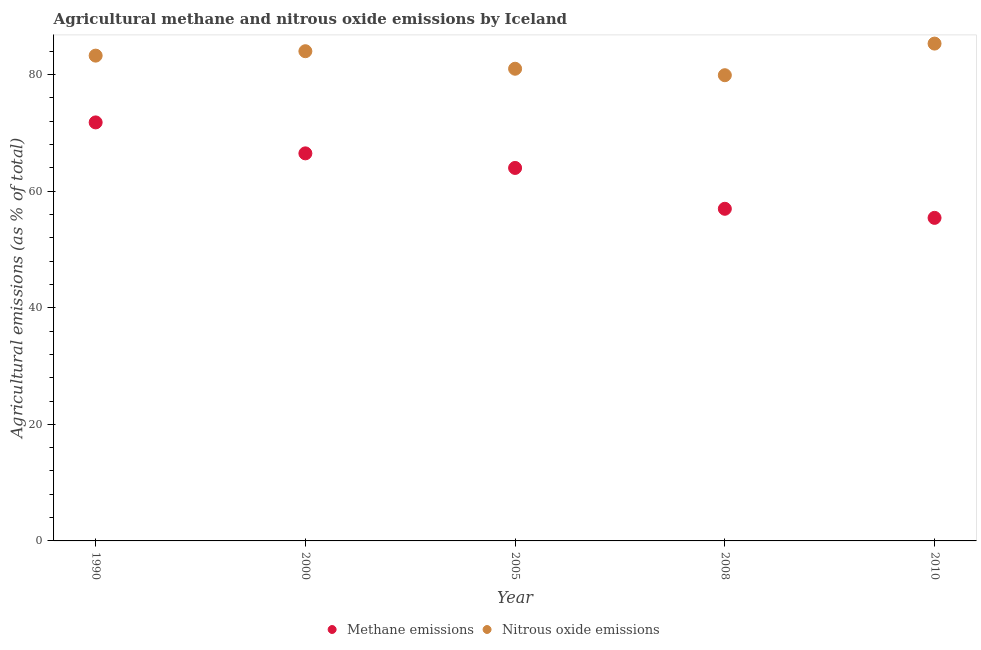How many different coloured dotlines are there?
Ensure brevity in your answer.  2. What is the amount of methane emissions in 2010?
Your answer should be very brief. 55.41. Across all years, what is the maximum amount of nitrous oxide emissions?
Your answer should be compact. 85.31. Across all years, what is the minimum amount of methane emissions?
Provide a succinct answer. 55.41. What is the total amount of nitrous oxide emissions in the graph?
Keep it short and to the point. 413.43. What is the difference between the amount of methane emissions in 2000 and that in 2008?
Your answer should be very brief. 9.51. What is the difference between the amount of methane emissions in 2005 and the amount of nitrous oxide emissions in 2008?
Your answer should be compact. -15.91. What is the average amount of nitrous oxide emissions per year?
Offer a very short reply. 82.69. In the year 1990, what is the difference between the amount of nitrous oxide emissions and amount of methane emissions?
Keep it short and to the point. 11.45. In how many years, is the amount of methane emissions greater than 80 %?
Offer a terse response. 0. What is the ratio of the amount of nitrous oxide emissions in 2000 to that in 2005?
Ensure brevity in your answer.  1.04. What is the difference between the highest and the second highest amount of nitrous oxide emissions?
Your response must be concise. 1.31. What is the difference between the highest and the lowest amount of methane emissions?
Keep it short and to the point. 16.37. Is the amount of nitrous oxide emissions strictly greater than the amount of methane emissions over the years?
Your answer should be very brief. Yes. Is the amount of nitrous oxide emissions strictly less than the amount of methane emissions over the years?
Keep it short and to the point. No. What is the difference between two consecutive major ticks on the Y-axis?
Ensure brevity in your answer.  20. Are the values on the major ticks of Y-axis written in scientific E-notation?
Provide a short and direct response. No. Does the graph contain grids?
Make the answer very short. No. How many legend labels are there?
Ensure brevity in your answer.  2. What is the title of the graph?
Your answer should be compact. Agricultural methane and nitrous oxide emissions by Iceland. What is the label or title of the X-axis?
Make the answer very short. Year. What is the label or title of the Y-axis?
Your response must be concise. Agricultural emissions (as % of total). What is the Agricultural emissions (as % of total) of Methane emissions in 1990?
Your answer should be compact. 71.79. What is the Agricultural emissions (as % of total) in Nitrous oxide emissions in 1990?
Give a very brief answer. 83.24. What is the Agricultural emissions (as % of total) in Methane emissions in 2000?
Your answer should be compact. 66.48. What is the Agricultural emissions (as % of total) in Methane emissions in 2005?
Offer a very short reply. 63.98. What is the Agricultural emissions (as % of total) of Nitrous oxide emissions in 2005?
Your response must be concise. 80.99. What is the Agricultural emissions (as % of total) of Methane emissions in 2008?
Your response must be concise. 56.97. What is the Agricultural emissions (as % of total) in Nitrous oxide emissions in 2008?
Give a very brief answer. 79.88. What is the Agricultural emissions (as % of total) of Methane emissions in 2010?
Your answer should be compact. 55.41. What is the Agricultural emissions (as % of total) in Nitrous oxide emissions in 2010?
Your answer should be very brief. 85.31. Across all years, what is the maximum Agricultural emissions (as % of total) of Methane emissions?
Keep it short and to the point. 71.79. Across all years, what is the maximum Agricultural emissions (as % of total) in Nitrous oxide emissions?
Your answer should be very brief. 85.31. Across all years, what is the minimum Agricultural emissions (as % of total) of Methane emissions?
Provide a short and direct response. 55.41. Across all years, what is the minimum Agricultural emissions (as % of total) in Nitrous oxide emissions?
Make the answer very short. 79.88. What is the total Agricultural emissions (as % of total) in Methane emissions in the graph?
Give a very brief answer. 314.63. What is the total Agricultural emissions (as % of total) in Nitrous oxide emissions in the graph?
Your response must be concise. 413.43. What is the difference between the Agricultural emissions (as % of total) in Methane emissions in 1990 and that in 2000?
Make the answer very short. 5.31. What is the difference between the Agricultural emissions (as % of total) of Nitrous oxide emissions in 1990 and that in 2000?
Your answer should be very brief. -0.76. What is the difference between the Agricultural emissions (as % of total) of Methane emissions in 1990 and that in 2005?
Provide a short and direct response. 7.81. What is the difference between the Agricultural emissions (as % of total) in Nitrous oxide emissions in 1990 and that in 2005?
Offer a terse response. 2.25. What is the difference between the Agricultural emissions (as % of total) of Methane emissions in 1990 and that in 2008?
Your answer should be very brief. 14.82. What is the difference between the Agricultural emissions (as % of total) of Nitrous oxide emissions in 1990 and that in 2008?
Your answer should be compact. 3.36. What is the difference between the Agricultural emissions (as % of total) of Methane emissions in 1990 and that in 2010?
Make the answer very short. 16.37. What is the difference between the Agricultural emissions (as % of total) in Nitrous oxide emissions in 1990 and that in 2010?
Give a very brief answer. -2.07. What is the difference between the Agricultural emissions (as % of total) in Methane emissions in 2000 and that in 2005?
Offer a very short reply. 2.5. What is the difference between the Agricultural emissions (as % of total) in Nitrous oxide emissions in 2000 and that in 2005?
Make the answer very short. 3.01. What is the difference between the Agricultural emissions (as % of total) in Methane emissions in 2000 and that in 2008?
Offer a very short reply. 9.51. What is the difference between the Agricultural emissions (as % of total) of Nitrous oxide emissions in 2000 and that in 2008?
Make the answer very short. 4.12. What is the difference between the Agricultural emissions (as % of total) in Methane emissions in 2000 and that in 2010?
Your response must be concise. 11.06. What is the difference between the Agricultural emissions (as % of total) of Nitrous oxide emissions in 2000 and that in 2010?
Offer a very short reply. -1.31. What is the difference between the Agricultural emissions (as % of total) of Methane emissions in 2005 and that in 2008?
Offer a terse response. 7.01. What is the difference between the Agricultural emissions (as % of total) of Nitrous oxide emissions in 2005 and that in 2008?
Provide a succinct answer. 1.11. What is the difference between the Agricultural emissions (as % of total) of Methane emissions in 2005 and that in 2010?
Provide a short and direct response. 8.56. What is the difference between the Agricultural emissions (as % of total) of Nitrous oxide emissions in 2005 and that in 2010?
Ensure brevity in your answer.  -4.31. What is the difference between the Agricultural emissions (as % of total) in Methane emissions in 2008 and that in 2010?
Ensure brevity in your answer.  1.56. What is the difference between the Agricultural emissions (as % of total) in Nitrous oxide emissions in 2008 and that in 2010?
Your response must be concise. -5.42. What is the difference between the Agricultural emissions (as % of total) in Methane emissions in 1990 and the Agricultural emissions (as % of total) in Nitrous oxide emissions in 2000?
Offer a very short reply. -12.21. What is the difference between the Agricultural emissions (as % of total) in Methane emissions in 1990 and the Agricultural emissions (as % of total) in Nitrous oxide emissions in 2005?
Offer a very short reply. -9.2. What is the difference between the Agricultural emissions (as % of total) of Methane emissions in 1990 and the Agricultural emissions (as % of total) of Nitrous oxide emissions in 2008?
Ensure brevity in your answer.  -8.1. What is the difference between the Agricultural emissions (as % of total) of Methane emissions in 1990 and the Agricultural emissions (as % of total) of Nitrous oxide emissions in 2010?
Make the answer very short. -13.52. What is the difference between the Agricultural emissions (as % of total) of Methane emissions in 2000 and the Agricultural emissions (as % of total) of Nitrous oxide emissions in 2005?
Offer a very short reply. -14.51. What is the difference between the Agricultural emissions (as % of total) of Methane emissions in 2000 and the Agricultural emissions (as % of total) of Nitrous oxide emissions in 2008?
Offer a very short reply. -13.41. What is the difference between the Agricultural emissions (as % of total) in Methane emissions in 2000 and the Agricultural emissions (as % of total) in Nitrous oxide emissions in 2010?
Give a very brief answer. -18.83. What is the difference between the Agricultural emissions (as % of total) of Methane emissions in 2005 and the Agricultural emissions (as % of total) of Nitrous oxide emissions in 2008?
Your response must be concise. -15.91. What is the difference between the Agricultural emissions (as % of total) in Methane emissions in 2005 and the Agricultural emissions (as % of total) in Nitrous oxide emissions in 2010?
Keep it short and to the point. -21.33. What is the difference between the Agricultural emissions (as % of total) of Methane emissions in 2008 and the Agricultural emissions (as % of total) of Nitrous oxide emissions in 2010?
Keep it short and to the point. -28.34. What is the average Agricultural emissions (as % of total) of Methane emissions per year?
Offer a very short reply. 62.93. What is the average Agricultural emissions (as % of total) of Nitrous oxide emissions per year?
Offer a terse response. 82.69. In the year 1990, what is the difference between the Agricultural emissions (as % of total) in Methane emissions and Agricultural emissions (as % of total) in Nitrous oxide emissions?
Make the answer very short. -11.45. In the year 2000, what is the difference between the Agricultural emissions (as % of total) in Methane emissions and Agricultural emissions (as % of total) in Nitrous oxide emissions?
Provide a succinct answer. -17.52. In the year 2005, what is the difference between the Agricultural emissions (as % of total) of Methane emissions and Agricultural emissions (as % of total) of Nitrous oxide emissions?
Provide a short and direct response. -17.02. In the year 2008, what is the difference between the Agricultural emissions (as % of total) of Methane emissions and Agricultural emissions (as % of total) of Nitrous oxide emissions?
Ensure brevity in your answer.  -22.91. In the year 2010, what is the difference between the Agricultural emissions (as % of total) in Methane emissions and Agricultural emissions (as % of total) in Nitrous oxide emissions?
Ensure brevity in your answer.  -29.89. What is the ratio of the Agricultural emissions (as % of total) of Methane emissions in 1990 to that in 2000?
Keep it short and to the point. 1.08. What is the ratio of the Agricultural emissions (as % of total) of Methane emissions in 1990 to that in 2005?
Keep it short and to the point. 1.12. What is the ratio of the Agricultural emissions (as % of total) of Nitrous oxide emissions in 1990 to that in 2005?
Your answer should be very brief. 1.03. What is the ratio of the Agricultural emissions (as % of total) in Methane emissions in 1990 to that in 2008?
Your response must be concise. 1.26. What is the ratio of the Agricultural emissions (as % of total) in Nitrous oxide emissions in 1990 to that in 2008?
Keep it short and to the point. 1.04. What is the ratio of the Agricultural emissions (as % of total) in Methane emissions in 1990 to that in 2010?
Make the answer very short. 1.3. What is the ratio of the Agricultural emissions (as % of total) in Nitrous oxide emissions in 1990 to that in 2010?
Give a very brief answer. 0.98. What is the ratio of the Agricultural emissions (as % of total) in Methane emissions in 2000 to that in 2005?
Make the answer very short. 1.04. What is the ratio of the Agricultural emissions (as % of total) in Nitrous oxide emissions in 2000 to that in 2005?
Offer a very short reply. 1.04. What is the ratio of the Agricultural emissions (as % of total) of Methane emissions in 2000 to that in 2008?
Your response must be concise. 1.17. What is the ratio of the Agricultural emissions (as % of total) of Nitrous oxide emissions in 2000 to that in 2008?
Ensure brevity in your answer.  1.05. What is the ratio of the Agricultural emissions (as % of total) of Methane emissions in 2000 to that in 2010?
Provide a short and direct response. 1.2. What is the ratio of the Agricultural emissions (as % of total) of Nitrous oxide emissions in 2000 to that in 2010?
Offer a very short reply. 0.98. What is the ratio of the Agricultural emissions (as % of total) of Methane emissions in 2005 to that in 2008?
Your answer should be very brief. 1.12. What is the ratio of the Agricultural emissions (as % of total) of Nitrous oxide emissions in 2005 to that in 2008?
Give a very brief answer. 1.01. What is the ratio of the Agricultural emissions (as % of total) in Methane emissions in 2005 to that in 2010?
Offer a very short reply. 1.15. What is the ratio of the Agricultural emissions (as % of total) of Nitrous oxide emissions in 2005 to that in 2010?
Offer a very short reply. 0.95. What is the ratio of the Agricultural emissions (as % of total) of Methane emissions in 2008 to that in 2010?
Make the answer very short. 1.03. What is the ratio of the Agricultural emissions (as % of total) of Nitrous oxide emissions in 2008 to that in 2010?
Your answer should be compact. 0.94. What is the difference between the highest and the second highest Agricultural emissions (as % of total) in Methane emissions?
Your answer should be very brief. 5.31. What is the difference between the highest and the second highest Agricultural emissions (as % of total) in Nitrous oxide emissions?
Offer a very short reply. 1.31. What is the difference between the highest and the lowest Agricultural emissions (as % of total) of Methane emissions?
Your response must be concise. 16.37. What is the difference between the highest and the lowest Agricultural emissions (as % of total) in Nitrous oxide emissions?
Your response must be concise. 5.42. 